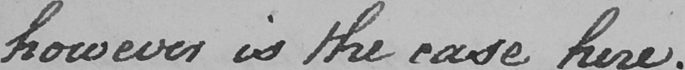Transcribe the text shown in this historical manuscript line. however is the ease here . 